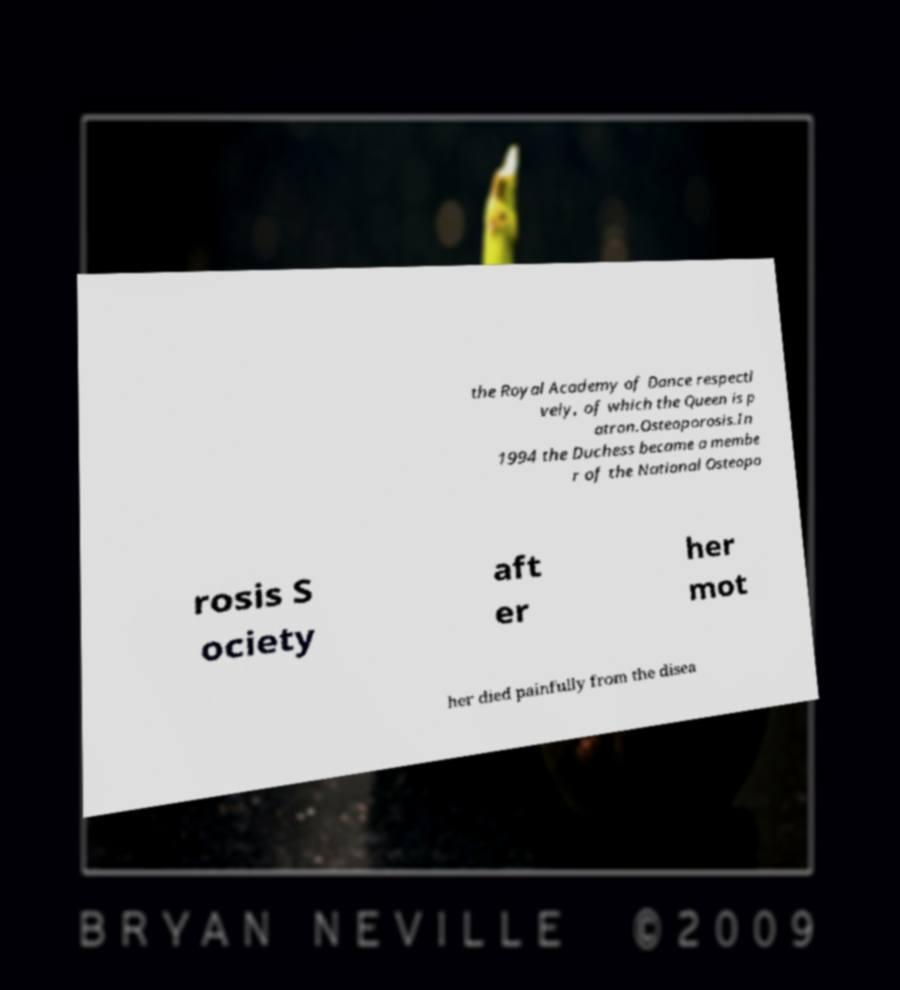Can you accurately transcribe the text from the provided image for me? the Royal Academy of Dance respecti vely, of which the Queen is p atron.Osteoporosis.In 1994 the Duchess became a membe r of the National Osteopo rosis S ociety aft er her mot her died painfully from the disea 